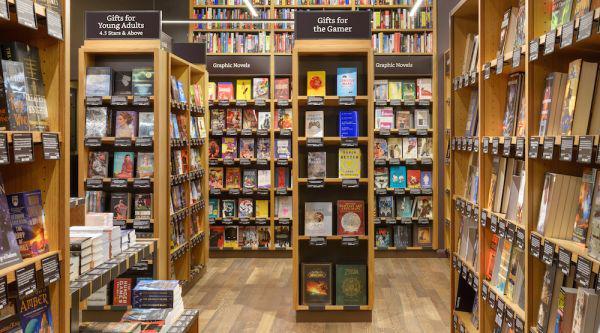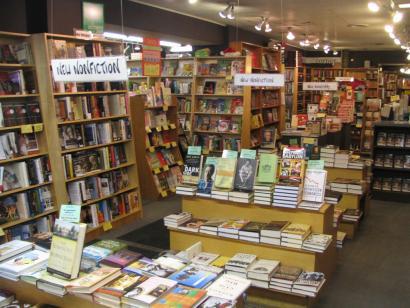The first image is the image on the left, the second image is the image on the right. Given the left and right images, does the statement "There is a thin and tall standalone bookshelf in the centre of the left image." hold true? Answer yes or no. Yes. 